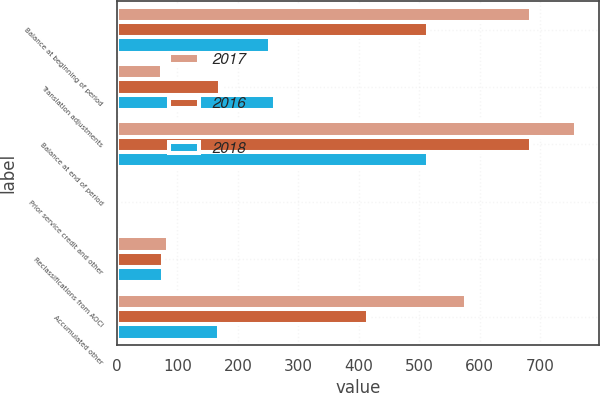Convert chart to OTSL. <chart><loc_0><loc_0><loc_500><loc_500><stacked_bar_chart><ecel><fcel>Balance at beginning of period<fcel>Translation adjustments<fcel>Balance at end of period<fcel>Prior service credit and other<fcel>Reclassifications from AOCI<fcel>Accumulated other<nl><fcel>2017<fcel>685<fcel>74<fcel>759<fcel>4<fcel>85<fcel>578<nl><fcel>2016<fcel>514<fcel>171<fcel>685<fcel>1<fcel>76<fcel>415<nl><fcel>2018<fcel>253<fcel>261<fcel>514<fcel>4<fcel>76<fcel>169<nl></chart> 